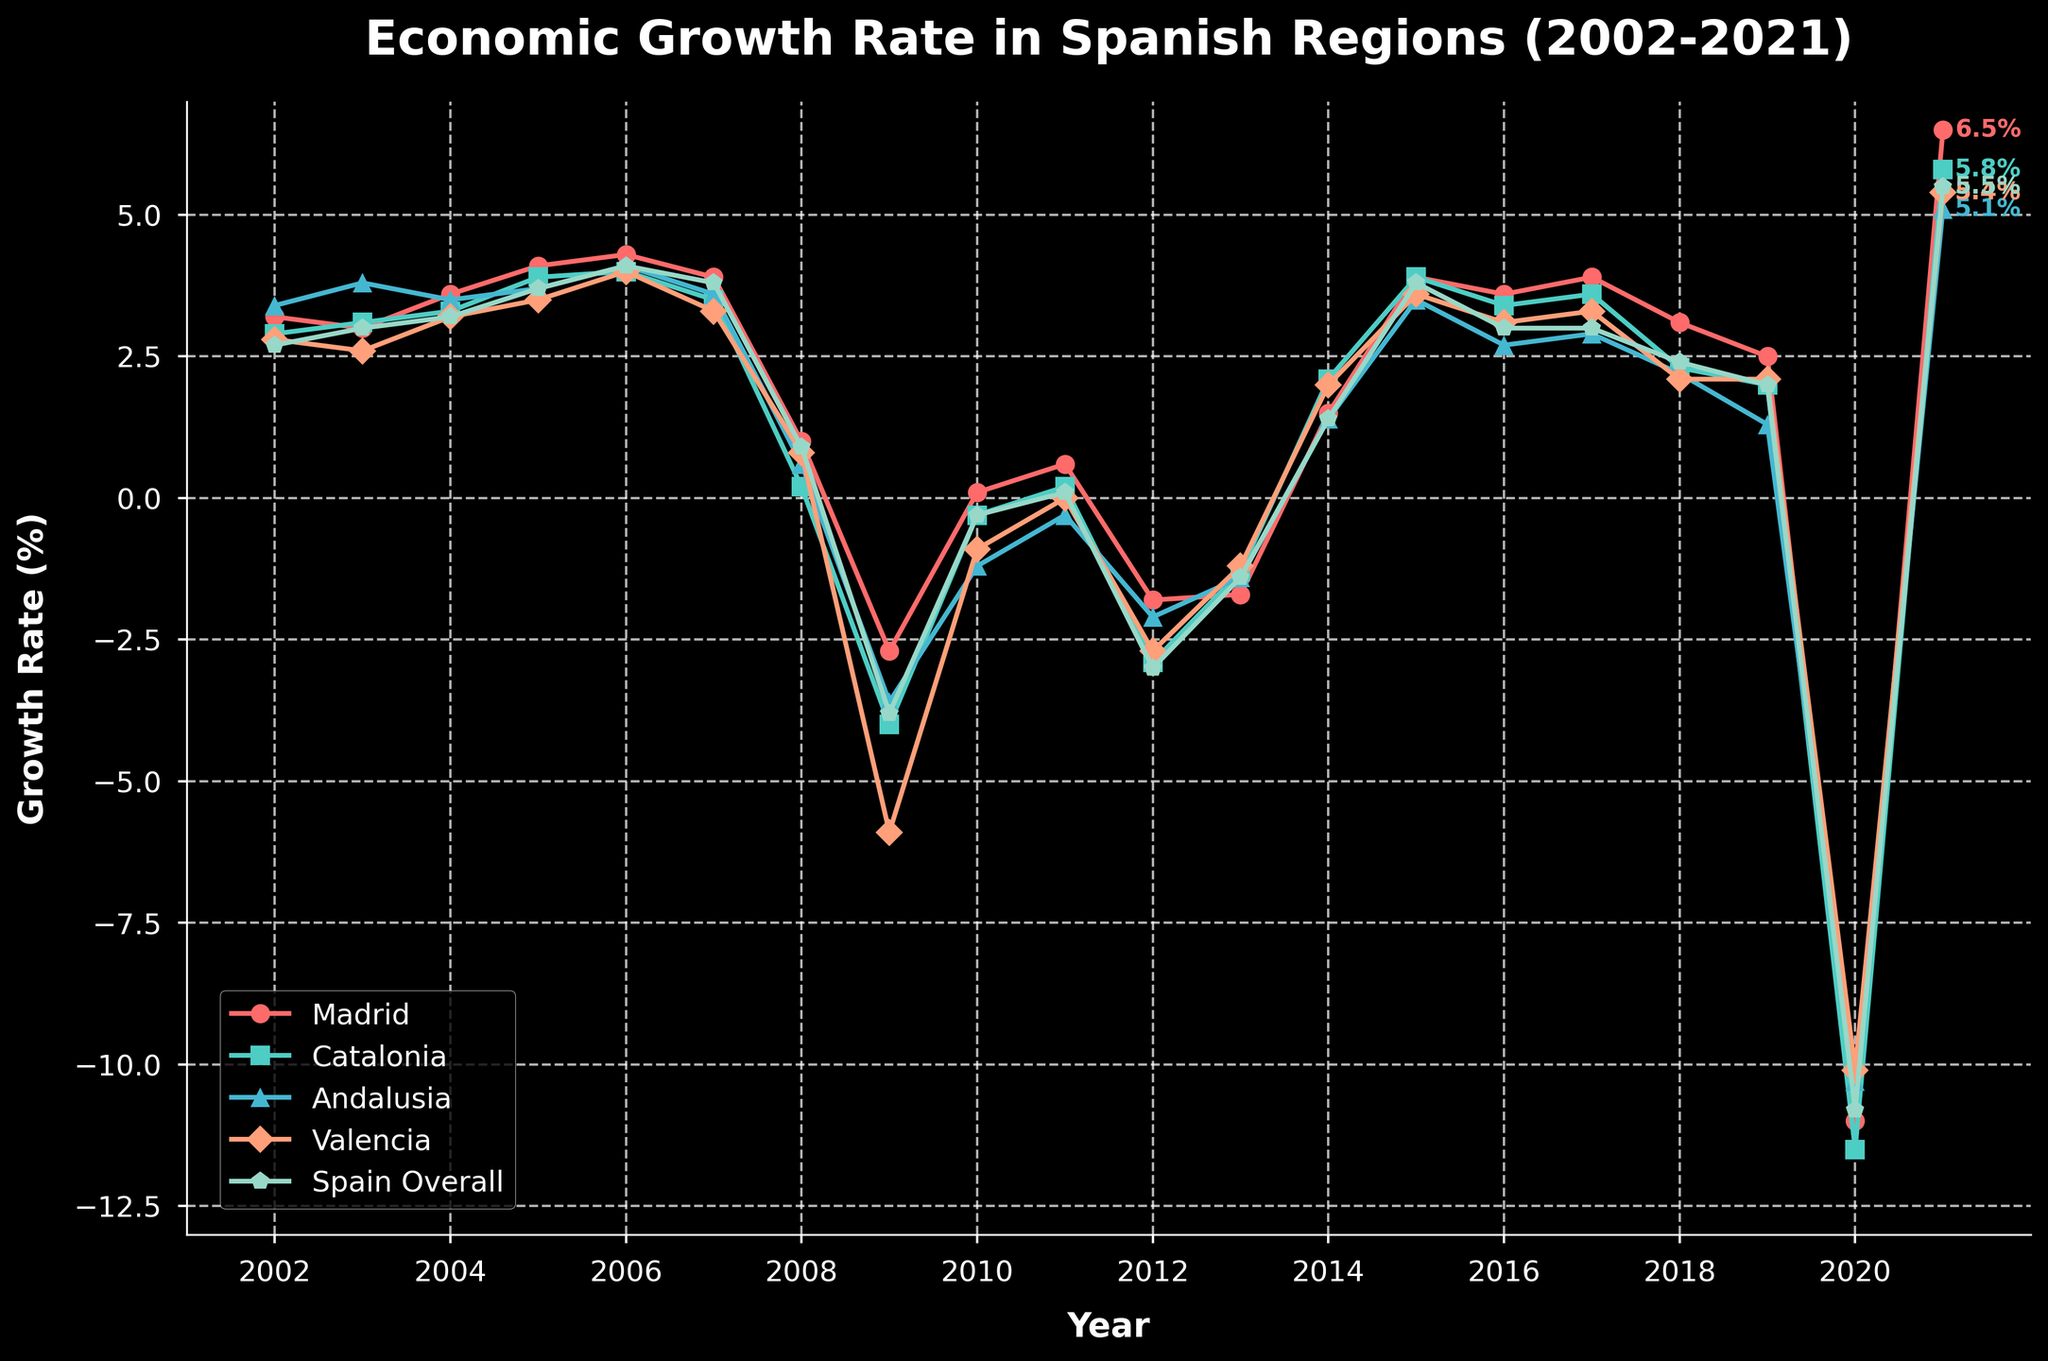What's the difference in economic growth rate between Madrid and Catalonia in 2021? To find the difference, look at the end values for both Madrid and Catalonia in 2021. Madrid has 6.5% and Catalonia has 5.8%. So, 6.5% - 5.8% = 0.7%.
Answer: 0.7% In which year did Madrid have its highest economic growth rate, and what was the value? Look for the peak value in the line representing Madrid. The highest value is in 2006 with a growth rate of 4.3%.
Answer: 2006, 4.3% Which region had the lowest economic growth rate in 2020, and what was the value? Look at the values for each region in 2020. Catalonia is the lowest with -11.5%.
Answer: Catalonia, -11.5% Did Madrid ever have a negative growth rate? If so, in which years? Observe the line for Madrid for any points below the horizontal zero line. Madrid had negative growth rates in 2009 (-2.7%), 2012 (-1.8%), and 2020 (-11.0%).
Answer: 2009, 2012, 2020 What’s the average economic growth rate of Spain overall from 2002 to 2021? Sum the data points for Spain Overall from 2002 to 2021 and divide by the number of years (20). The sum is 30.1% so the average is 30.1/20 = 1.505%.
Answer: 1.505% Which region showed the highest growth rate recovery from 2020 to 2021? Calculate the difference between 2021 and 2020 growth rates for each region. The differences are Madrid (17.5%), Catalonia (17.3%), Andalusia (15.4%), Valencia (15.5%), Spain Overall (16.3%). Madrid has the highest growth rate recovery.
Answer: Madrid How does the trend in economic growth for Madrid compare to Andalusia from 2008 to 2012? Analyze the lines for Madrid and Andalusia from 2008 to 2012. Both regions show a significant decline in 2009, slight recovery, and then another decline. However, Andalusia's decline is more severe in 2009.
Answer: Similar but Andalusia's decline is more severe in 2009 What is the overall trend observed in Valencia's economic growth rate from 2002 to 2021? Study the line for Valencia over the years. It sees a general rise until 2007, a sharp decline until 2013, a recovery until 2017, another slight decline, and then a steep drop in 2020 followed by recovery in 2021.
Answer: Rise, sharp decline, recovery, slight decline, steep drop, recovery How did the economic slowdown in 2009 impact Catalonia compared to Madrid? Look at the 2009 values for both regions. Catalonia has a sharp decline to -4.0% while Madrid declines to -2.7%. Catalonia's impact is more severe.
Answer: Catalonia was more severely impacted 